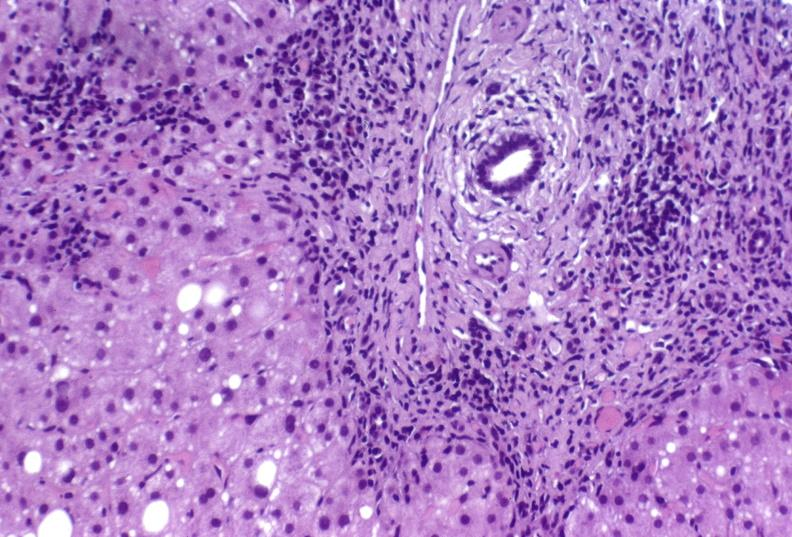s interesting case present?
Answer the question using a single word or phrase. No 